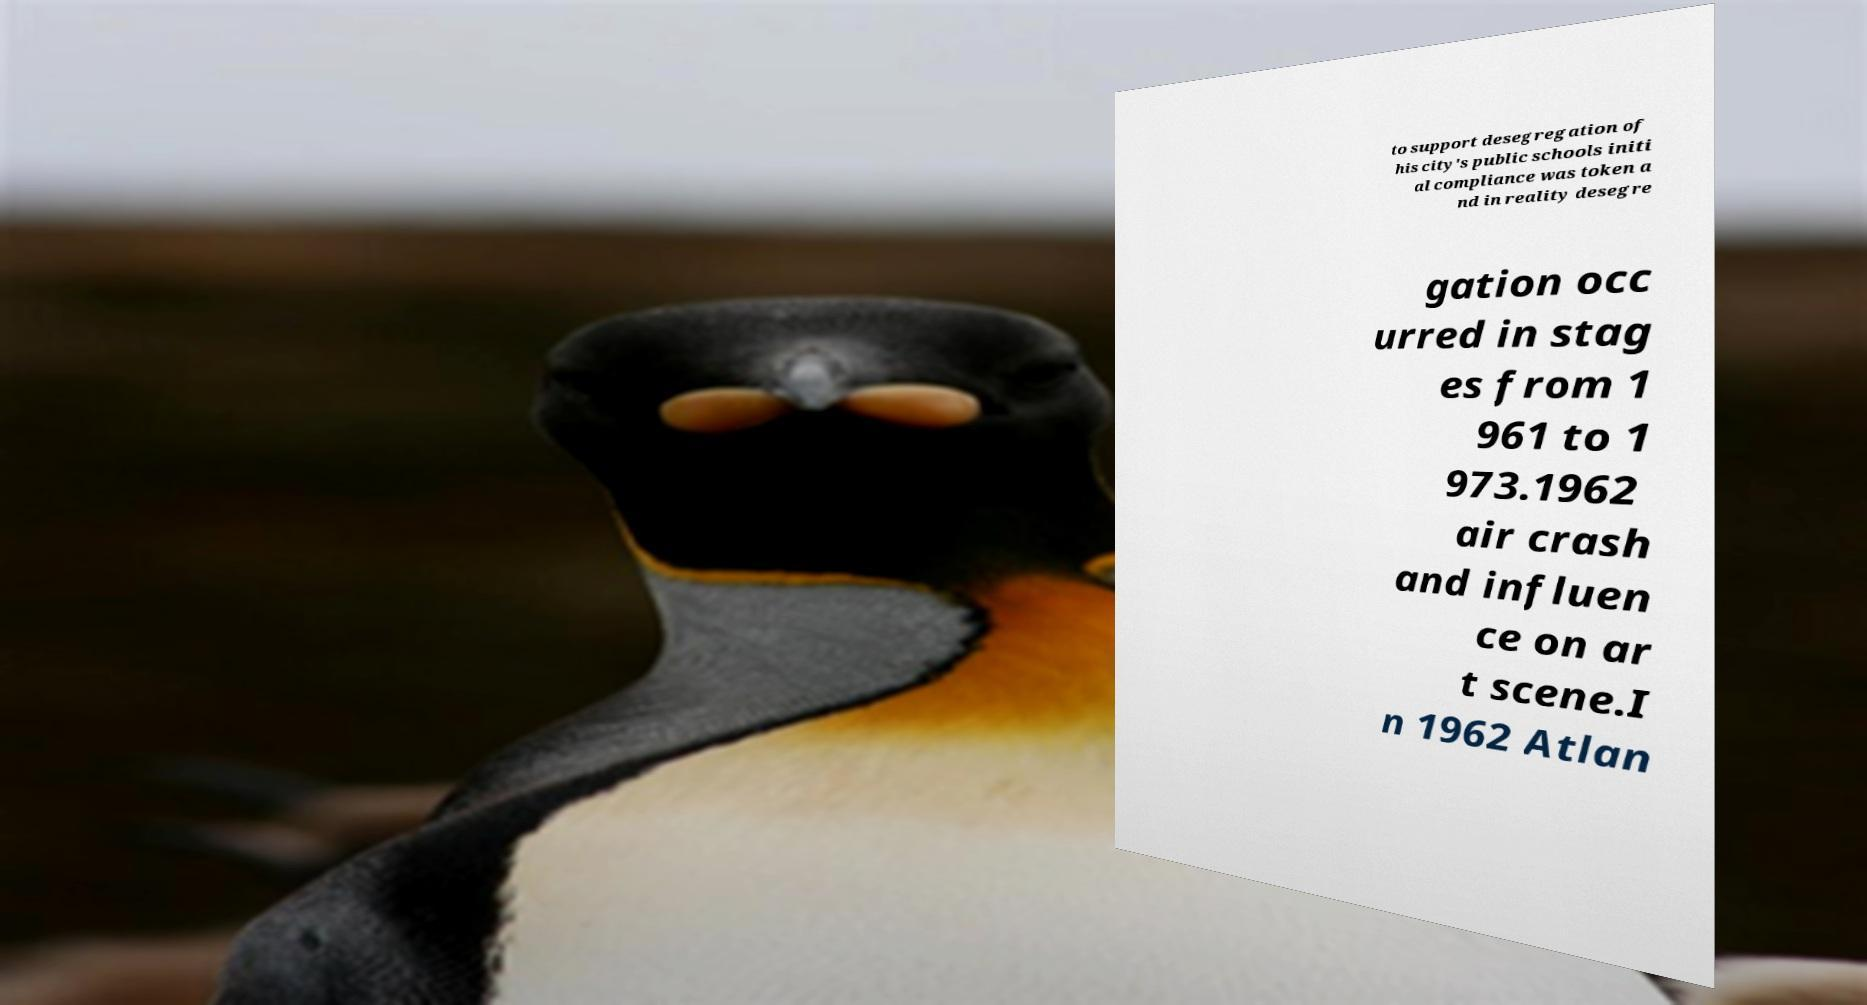Could you extract and type out the text from this image? to support desegregation of his city's public schools initi al compliance was token a nd in reality desegre gation occ urred in stag es from 1 961 to 1 973.1962 air crash and influen ce on ar t scene.I n 1962 Atlan 